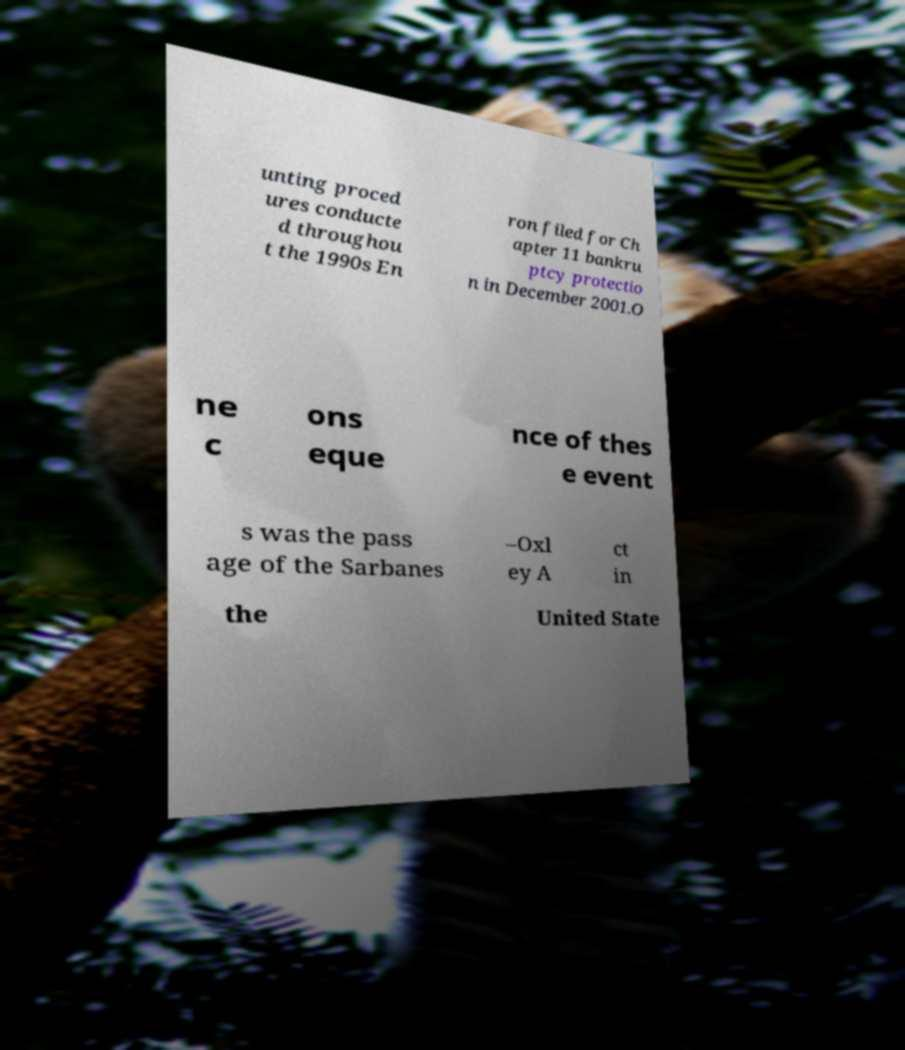Please identify and transcribe the text found in this image. unting proced ures conducte d throughou t the 1990s En ron filed for Ch apter 11 bankru ptcy protectio n in December 2001.O ne c ons eque nce of thes e event s was the pass age of the Sarbanes –Oxl ey A ct in the United State 